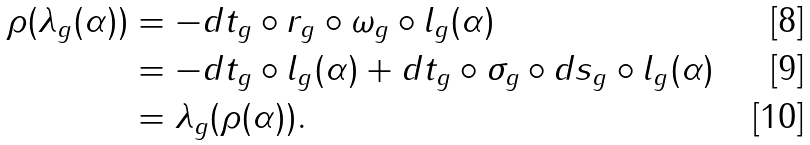<formula> <loc_0><loc_0><loc_500><loc_500>\rho ( \lambda _ { g } ( \alpha ) ) & = - d t _ { g } \circ r _ { g } \circ \omega _ { g } \circ l _ { g } ( \alpha ) \\ & = - d t _ { g } \circ l _ { g } ( \alpha ) + d t _ { g } \circ \sigma _ { g } \circ d s _ { g } \circ l _ { g } ( \alpha ) \\ & = \lambda _ { g } ( \rho ( \alpha ) ) .</formula> 